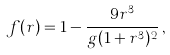Convert formula to latex. <formula><loc_0><loc_0><loc_500><loc_500>f ( r ) = 1 - \frac { 9 r ^ { 3 } } { g ( 1 + r ^ { 3 } ) ^ { 2 } } \, ,</formula> 